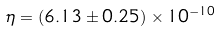<formula> <loc_0><loc_0><loc_500><loc_500>\eta = ( 6 . 1 3 \pm 0 . 2 5 ) \times 1 0 ^ { - 1 0 }</formula> 